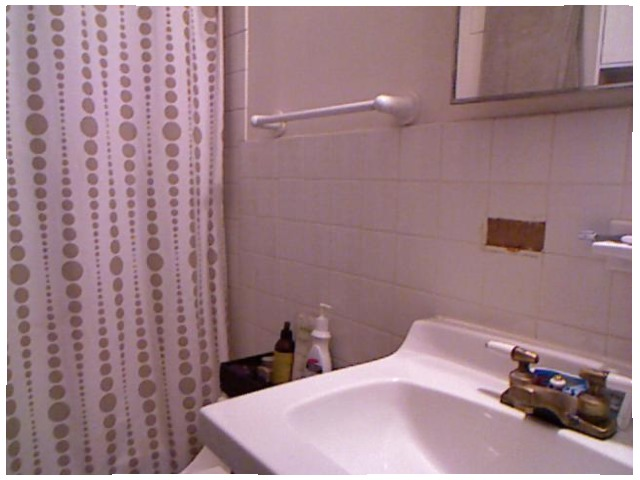<image>
Is the plastic on the tile? Yes. Looking at the image, I can see the plastic is positioned on top of the tile, with the tile providing support. Is the lotion on the sink? No. The lotion is not positioned on the sink. They may be near each other, but the lotion is not supported by or resting on top of the sink. 